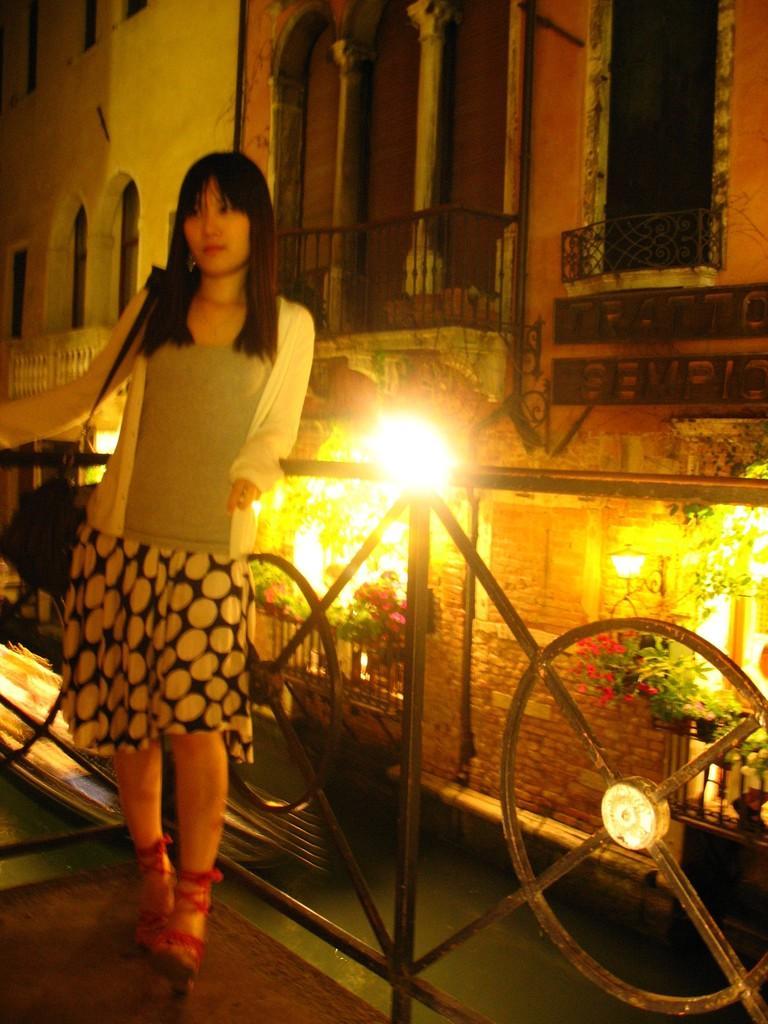Could you give a brief overview of what you see in this image? In this image there is a woman standing, she is wearing a bag, there are plants, there are lights, there are flowers, there is road, there are buildings, there is text on the building, there are pillars, there is a wooden floor towards the bottom of the image, there is a wall. 